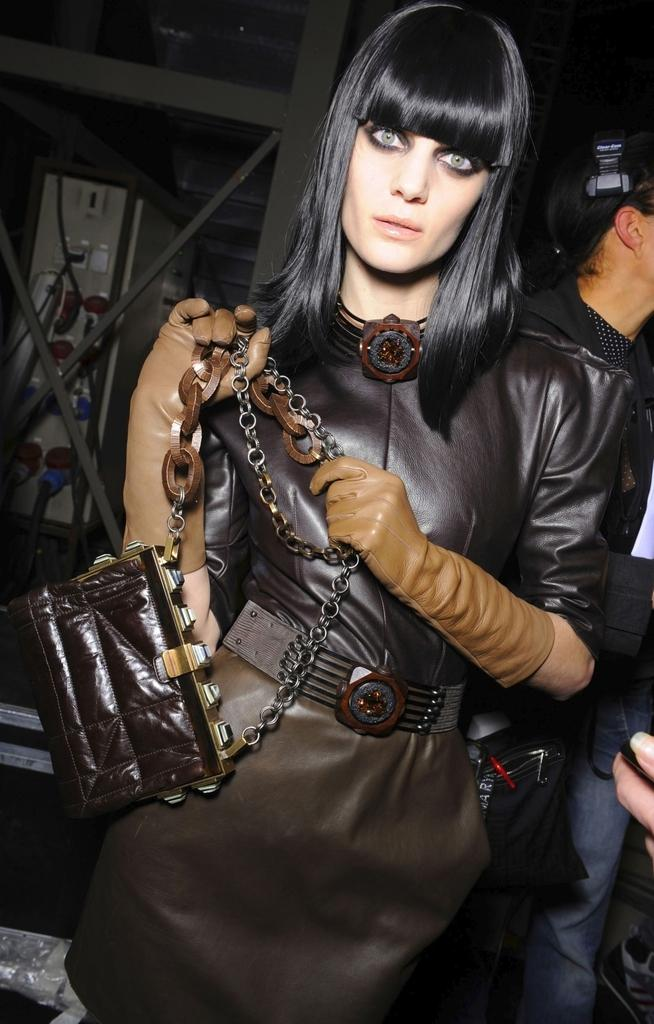Who is the main subject in the image? There is a woman in the image. What is the woman wearing on her hands? The woman is wearing gloves. What is the woman holding in the image? The woman is holding a handbag. Can you describe the man in the background of the image? There is a man in the background of the image, and he is standing. What type of lawyer is present at the party in the image? There is no party or lawyer present in the image; it only features a woman and a man in different positions. 